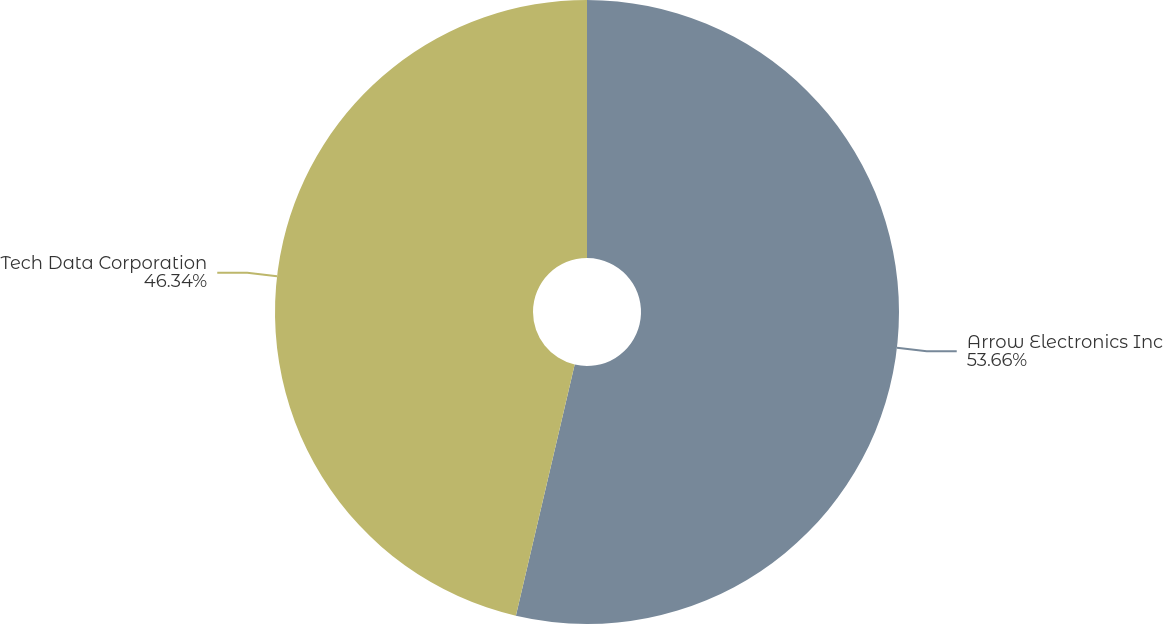Convert chart to OTSL. <chart><loc_0><loc_0><loc_500><loc_500><pie_chart><fcel>Arrow Electronics Inc<fcel>Tech Data Corporation<nl><fcel>53.66%<fcel>46.34%<nl></chart> 